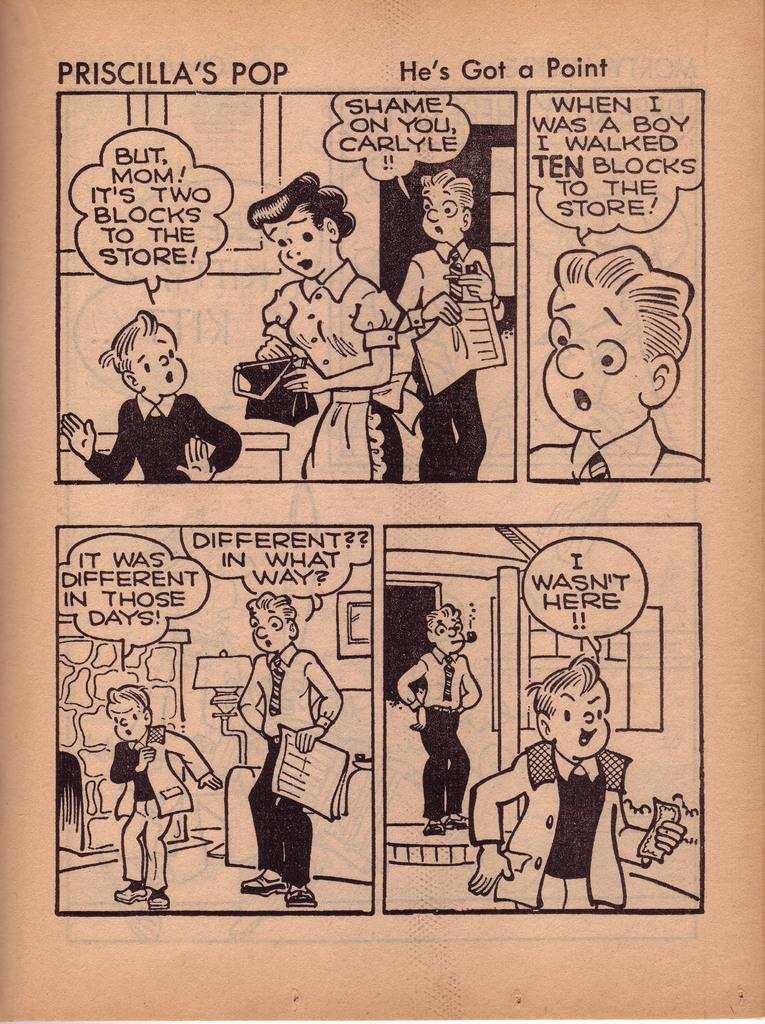What is the medium of the image? The image is on a paper. What can be found in the image besides the image of people? There is text and objects in the image. What type of liquid is being poured by the pig in the image? There is no pig present in the image, and therefore no liquid being poured. 